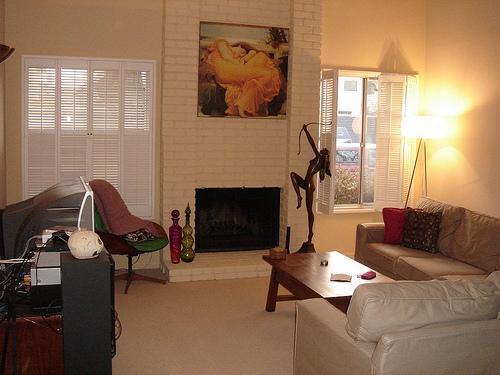How many paintings are there?
Give a very brief answer. 1. 